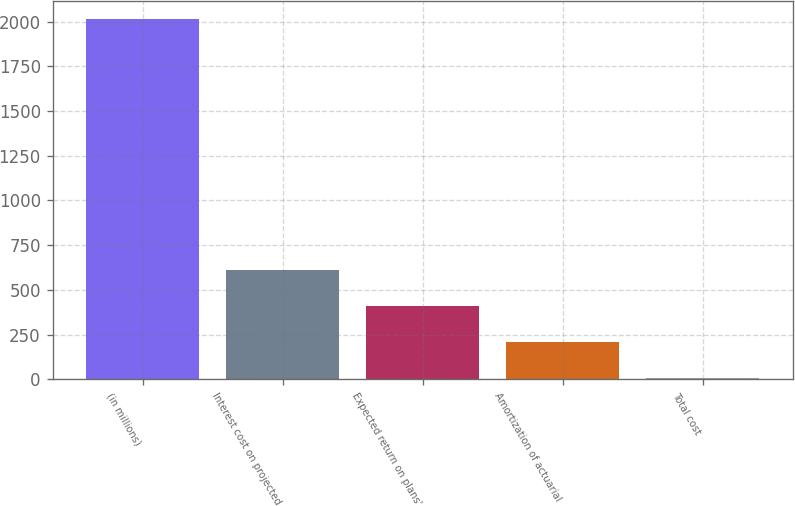Convert chart to OTSL. <chart><loc_0><loc_0><loc_500><loc_500><bar_chart><fcel>(in millions)<fcel>Interest cost on projected<fcel>Expected return on plans'<fcel>Amortization of actuarial<fcel>Total cost<nl><fcel>2016<fcel>608.3<fcel>407.2<fcel>206.1<fcel>5<nl></chart> 